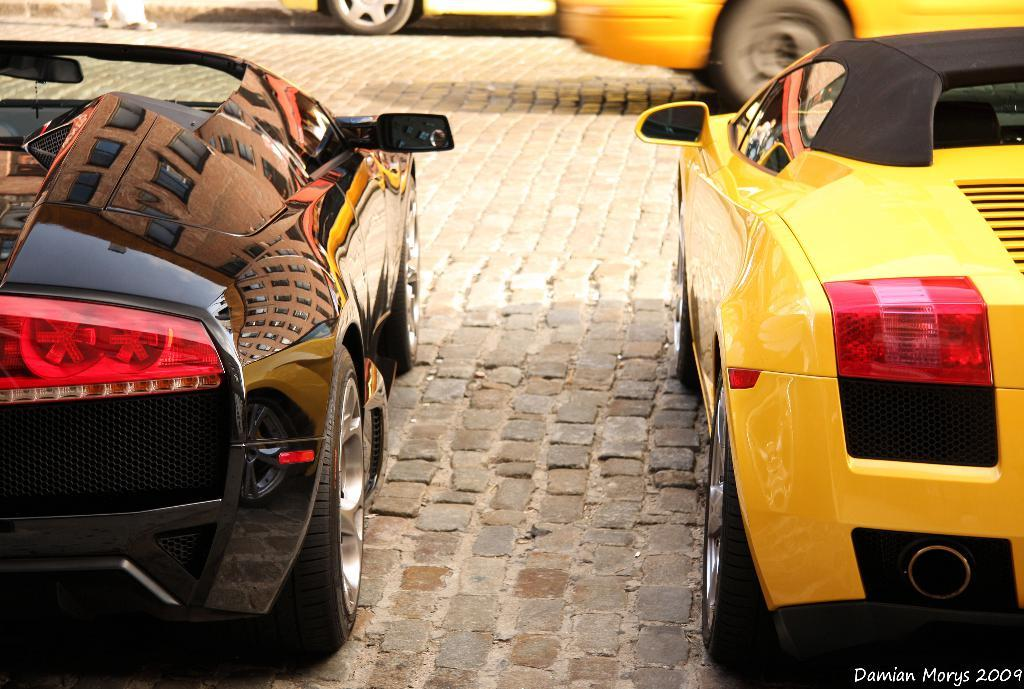How many vehicles can be seen in the image? There are four vehicles in the image. Can you describe the watermark in the image? There is a watermark in the bottom right corner of the image. What direction is the ball moving in the image? There is no ball present in the image, so it is not possible to determine the direction of its movement. 